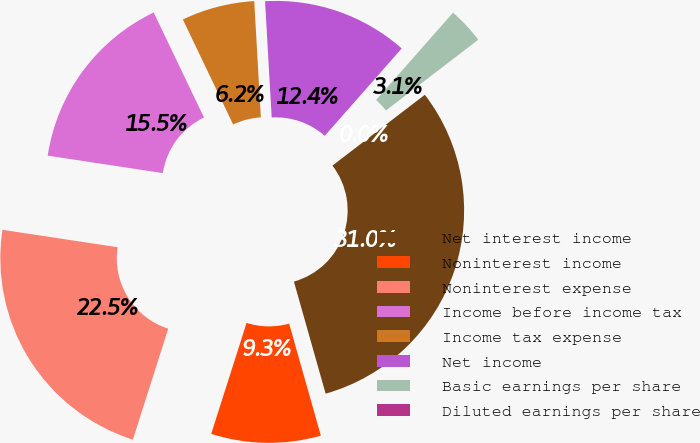Convert chart. <chart><loc_0><loc_0><loc_500><loc_500><pie_chart><fcel>Net interest income<fcel>Noninterest income<fcel>Noninterest expense<fcel>Income before income tax<fcel>Income tax expense<fcel>Net income<fcel>Basic earnings per share<fcel>Diluted earnings per share<nl><fcel>31.01%<fcel>9.3%<fcel>22.48%<fcel>15.5%<fcel>6.2%<fcel>12.4%<fcel>3.1%<fcel>0.0%<nl></chart> 